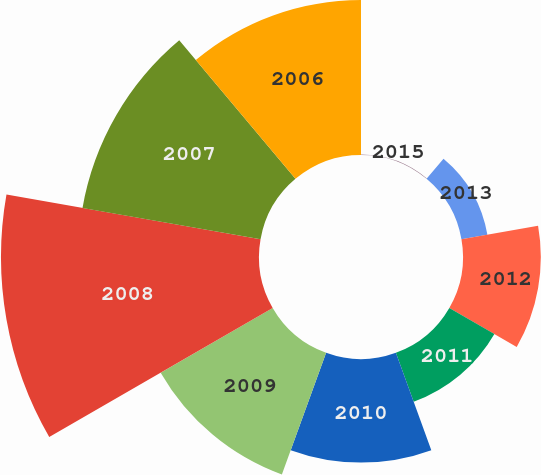<chart> <loc_0><loc_0><loc_500><loc_500><pie_chart><fcel>2015<fcel>2013<fcel>2012<fcel>2011<fcel>2010<fcel>2009<fcel>2008<fcel>2007<fcel>2006<nl><fcel>0.06%<fcel>2.68%<fcel>7.91%<fcel>5.29%<fcel>10.53%<fcel>13.15%<fcel>26.23%<fcel>18.38%<fcel>15.76%<nl></chart> 